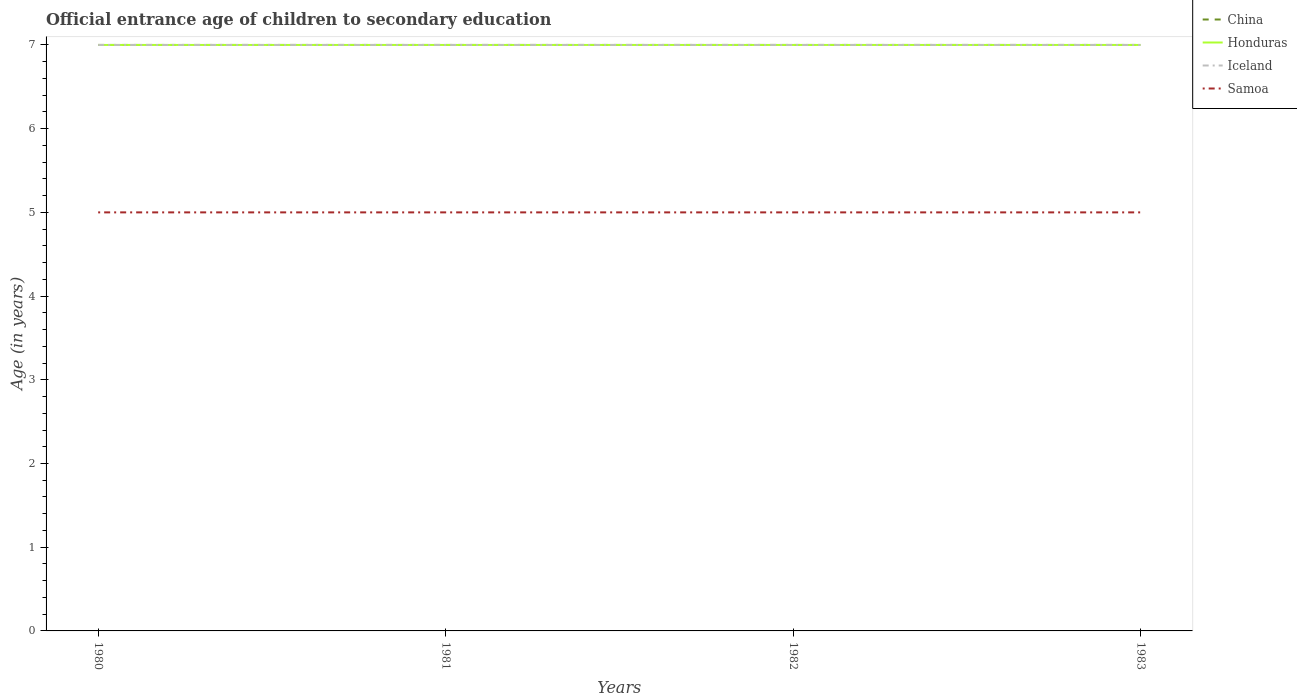How many different coloured lines are there?
Ensure brevity in your answer.  4. Does the line corresponding to Iceland intersect with the line corresponding to Samoa?
Keep it short and to the point. No. Across all years, what is the maximum secondary school starting age of children in Honduras?
Your response must be concise. 7. What is the total secondary school starting age of children in Samoa in the graph?
Provide a succinct answer. 0. What is the difference between the highest and the second highest secondary school starting age of children in Iceland?
Make the answer very short. 0. What is the difference between the highest and the lowest secondary school starting age of children in China?
Keep it short and to the point. 0. How many lines are there?
Make the answer very short. 4. Are the values on the major ticks of Y-axis written in scientific E-notation?
Your answer should be very brief. No. Where does the legend appear in the graph?
Your answer should be compact. Top right. How many legend labels are there?
Ensure brevity in your answer.  4. What is the title of the graph?
Your response must be concise. Official entrance age of children to secondary education. What is the label or title of the Y-axis?
Your answer should be compact. Age (in years). What is the Age (in years) of Iceland in 1980?
Offer a very short reply. 7. What is the Age (in years) of China in 1981?
Provide a succinct answer. 7. What is the Age (in years) of Honduras in 1981?
Make the answer very short. 7. What is the Age (in years) in Iceland in 1981?
Offer a very short reply. 7. What is the Age (in years) of Samoa in 1981?
Give a very brief answer. 5. What is the Age (in years) in China in 1982?
Provide a short and direct response. 7. What is the Age (in years) in Honduras in 1982?
Your answer should be very brief. 7. What is the Age (in years) of Iceland in 1982?
Offer a terse response. 7. What is the Age (in years) of China in 1983?
Your answer should be compact. 7. What is the Age (in years) of Honduras in 1983?
Provide a succinct answer. 7. What is the Age (in years) in Samoa in 1983?
Ensure brevity in your answer.  5. Across all years, what is the maximum Age (in years) of Honduras?
Your response must be concise. 7. Across all years, what is the maximum Age (in years) in Iceland?
Offer a very short reply. 7. Across all years, what is the maximum Age (in years) of Samoa?
Provide a short and direct response. 5. Across all years, what is the minimum Age (in years) of Honduras?
Offer a very short reply. 7. What is the total Age (in years) of China in the graph?
Provide a succinct answer. 28. What is the total Age (in years) of Honduras in the graph?
Your answer should be compact. 28. What is the total Age (in years) in Iceland in the graph?
Offer a terse response. 28. What is the total Age (in years) of Samoa in the graph?
Give a very brief answer. 20. What is the difference between the Age (in years) of Honduras in 1980 and that in 1981?
Ensure brevity in your answer.  0. What is the difference between the Age (in years) of Samoa in 1980 and that in 1981?
Keep it short and to the point. 0. What is the difference between the Age (in years) of Iceland in 1980 and that in 1982?
Provide a short and direct response. 0. What is the difference between the Age (in years) in Honduras in 1981 and that in 1982?
Your answer should be compact. 0. What is the difference between the Age (in years) of Iceland in 1981 and that in 1982?
Provide a succinct answer. 0. What is the difference between the Age (in years) in Samoa in 1981 and that in 1982?
Provide a short and direct response. 0. What is the difference between the Age (in years) of Samoa in 1981 and that in 1983?
Give a very brief answer. 0. What is the difference between the Age (in years) of China in 1982 and that in 1983?
Offer a very short reply. 0. What is the difference between the Age (in years) of Honduras in 1982 and that in 1983?
Provide a succinct answer. 0. What is the difference between the Age (in years) of Samoa in 1982 and that in 1983?
Provide a short and direct response. 0. What is the difference between the Age (in years) of China in 1980 and the Age (in years) of Samoa in 1981?
Ensure brevity in your answer.  2. What is the difference between the Age (in years) in Iceland in 1980 and the Age (in years) in Samoa in 1981?
Your answer should be very brief. 2. What is the difference between the Age (in years) of China in 1980 and the Age (in years) of Iceland in 1982?
Your response must be concise. 0. What is the difference between the Age (in years) in China in 1980 and the Age (in years) in Samoa in 1982?
Offer a very short reply. 2. What is the difference between the Age (in years) of Honduras in 1980 and the Age (in years) of Samoa in 1982?
Offer a very short reply. 2. What is the difference between the Age (in years) of China in 1980 and the Age (in years) of Honduras in 1983?
Your answer should be very brief. 0. What is the difference between the Age (in years) in China in 1980 and the Age (in years) in Iceland in 1983?
Ensure brevity in your answer.  0. What is the difference between the Age (in years) of Honduras in 1980 and the Age (in years) of Samoa in 1983?
Make the answer very short. 2. What is the difference between the Age (in years) in Honduras in 1981 and the Age (in years) in Iceland in 1982?
Your answer should be very brief. 0. What is the difference between the Age (in years) in Honduras in 1981 and the Age (in years) in Samoa in 1982?
Your answer should be very brief. 2. What is the difference between the Age (in years) of China in 1981 and the Age (in years) of Samoa in 1983?
Your answer should be compact. 2. What is the difference between the Age (in years) in Honduras in 1981 and the Age (in years) in Samoa in 1983?
Provide a succinct answer. 2. What is the difference between the Age (in years) in China in 1982 and the Age (in years) in Iceland in 1983?
Provide a succinct answer. 0. What is the difference between the Age (in years) in China in 1982 and the Age (in years) in Samoa in 1983?
Make the answer very short. 2. What is the average Age (in years) of China per year?
Make the answer very short. 7. What is the average Age (in years) in Samoa per year?
Ensure brevity in your answer.  5. In the year 1980, what is the difference between the Age (in years) in Honduras and Age (in years) in Samoa?
Give a very brief answer. 2. In the year 1981, what is the difference between the Age (in years) of Honduras and Age (in years) of Samoa?
Offer a terse response. 2. In the year 1981, what is the difference between the Age (in years) in Iceland and Age (in years) in Samoa?
Ensure brevity in your answer.  2. In the year 1982, what is the difference between the Age (in years) in China and Age (in years) in Iceland?
Your response must be concise. 0. In the year 1982, what is the difference between the Age (in years) in Honduras and Age (in years) in Samoa?
Keep it short and to the point. 2. In the year 1982, what is the difference between the Age (in years) of Iceland and Age (in years) of Samoa?
Your answer should be very brief. 2. In the year 1983, what is the difference between the Age (in years) of Honduras and Age (in years) of Iceland?
Offer a terse response. 0. In the year 1983, what is the difference between the Age (in years) of Iceland and Age (in years) of Samoa?
Provide a succinct answer. 2. What is the ratio of the Age (in years) of Honduras in 1980 to that in 1981?
Provide a short and direct response. 1. What is the ratio of the Age (in years) in Samoa in 1980 to that in 1981?
Give a very brief answer. 1. What is the ratio of the Age (in years) in Honduras in 1980 to that in 1982?
Keep it short and to the point. 1. What is the ratio of the Age (in years) of Honduras in 1980 to that in 1983?
Offer a very short reply. 1. What is the ratio of the Age (in years) of China in 1981 to that in 1982?
Offer a very short reply. 1. What is the ratio of the Age (in years) in Honduras in 1981 to that in 1982?
Your answer should be very brief. 1. What is the ratio of the Age (in years) of Samoa in 1981 to that in 1982?
Provide a succinct answer. 1. What is the ratio of the Age (in years) of China in 1981 to that in 1983?
Your response must be concise. 1. What is the ratio of the Age (in years) of Honduras in 1981 to that in 1983?
Provide a short and direct response. 1. What is the ratio of the Age (in years) in China in 1982 to that in 1983?
Keep it short and to the point. 1. What is the ratio of the Age (in years) in Samoa in 1982 to that in 1983?
Give a very brief answer. 1. What is the difference between the highest and the second highest Age (in years) in Honduras?
Provide a succinct answer. 0. What is the difference between the highest and the lowest Age (in years) in China?
Provide a short and direct response. 0. What is the difference between the highest and the lowest Age (in years) in Iceland?
Ensure brevity in your answer.  0. What is the difference between the highest and the lowest Age (in years) of Samoa?
Give a very brief answer. 0. 